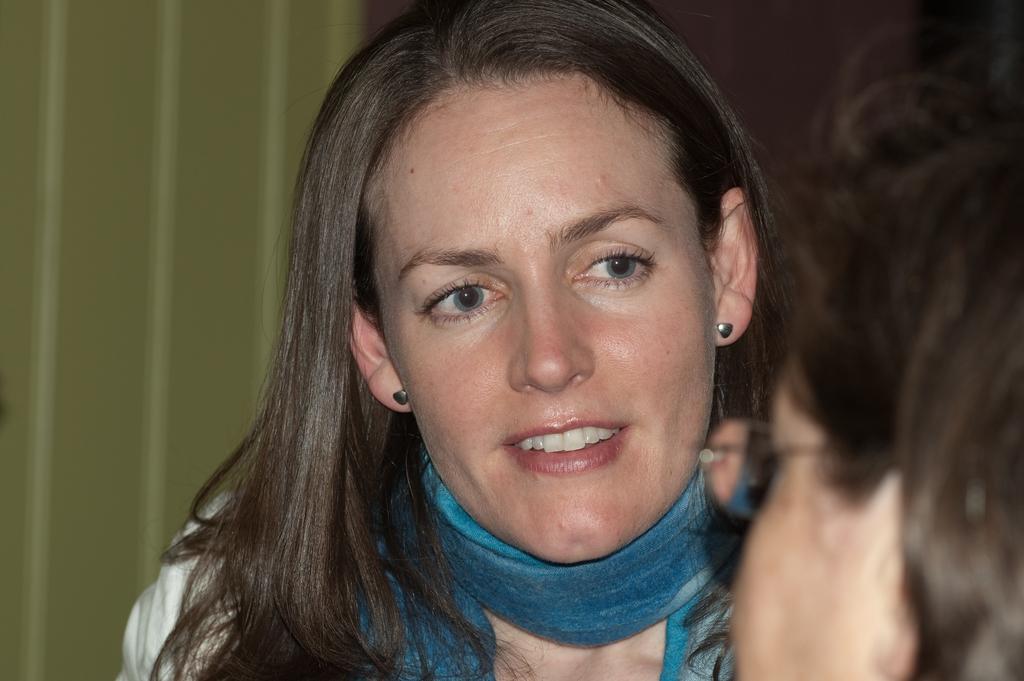Please provide a concise description of this image. In this image we can see two persons, among them one person is wearing the spectacles and in the background we can see the wall. 